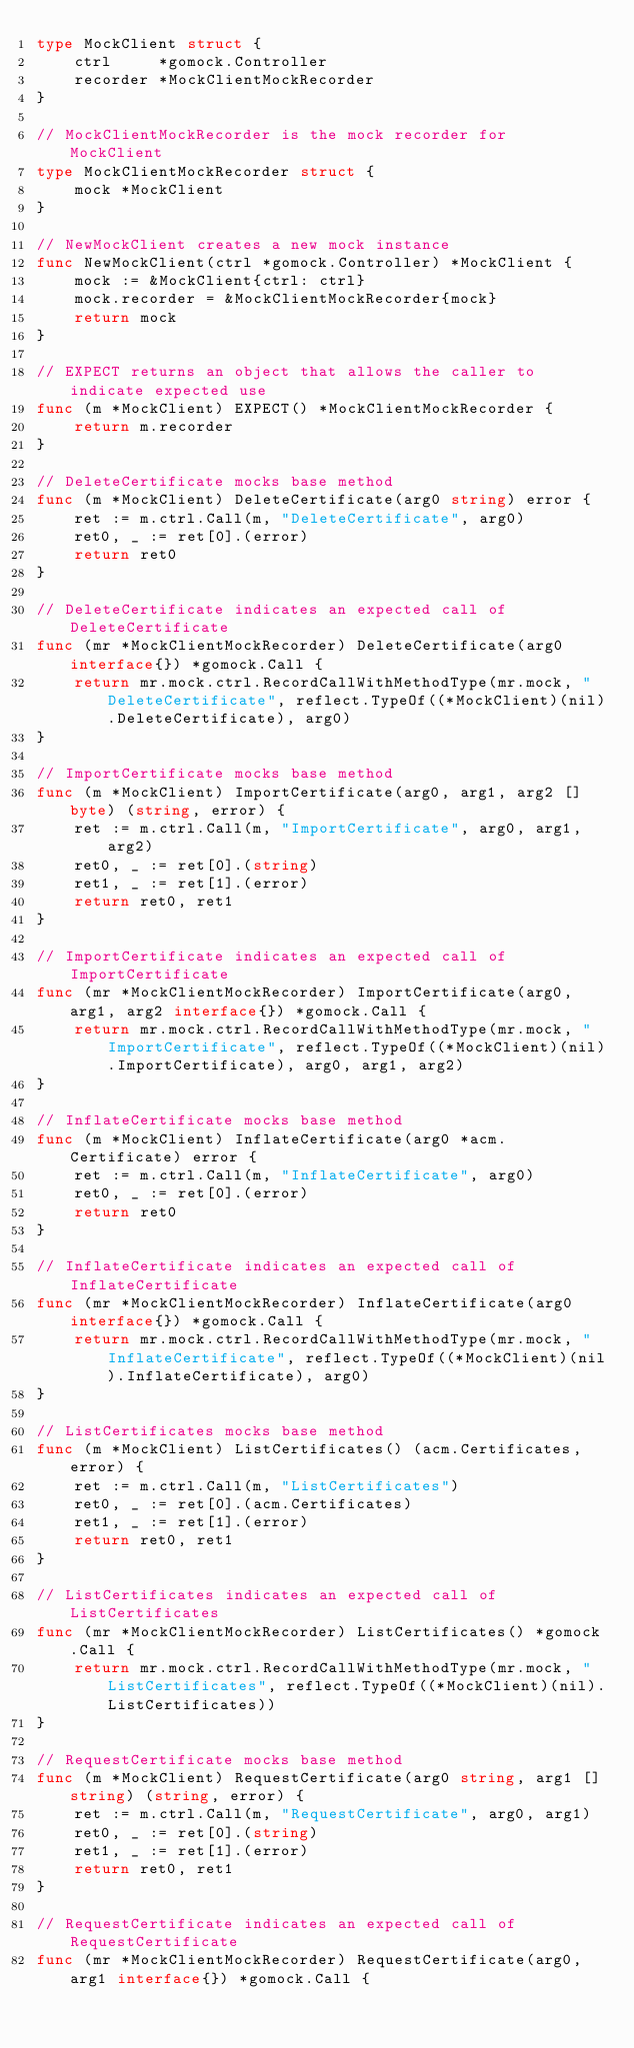<code> <loc_0><loc_0><loc_500><loc_500><_Go_>type MockClient struct {
	ctrl     *gomock.Controller
	recorder *MockClientMockRecorder
}

// MockClientMockRecorder is the mock recorder for MockClient
type MockClientMockRecorder struct {
	mock *MockClient
}

// NewMockClient creates a new mock instance
func NewMockClient(ctrl *gomock.Controller) *MockClient {
	mock := &MockClient{ctrl: ctrl}
	mock.recorder = &MockClientMockRecorder{mock}
	return mock
}

// EXPECT returns an object that allows the caller to indicate expected use
func (m *MockClient) EXPECT() *MockClientMockRecorder {
	return m.recorder
}

// DeleteCertificate mocks base method
func (m *MockClient) DeleteCertificate(arg0 string) error {
	ret := m.ctrl.Call(m, "DeleteCertificate", arg0)
	ret0, _ := ret[0].(error)
	return ret0
}

// DeleteCertificate indicates an expected call of DeleteCertificate
func (mr *MockClientMockRecorder) DeleteCertificate(arg0 interface{}) *gomock.Call {
	return mr.mock.ctrl.RecordCallWithMethodType(mr.mock, "DeleteCertificate", reflect.TypeOf((*MockClient)(nil).DeleteCertificate), arg0)
}

// ImportCertificate mocks base method
func (m *MockClient) ImportCertificate(arg0, arg1, arg2 []byte) (string, error) {
	ret := m.ctrl.Call(m, "ImportCertificate", arg0, arg1, arg2)
	ret0, _ := ret[0].(string)
	ret1, _ := ret[1].(error)
	return ret0, ret1
}

// ImportCertificate indicates an expected call of ImportCertificate
func (mr *MockClientMockRecorder) ImportCertificate(arg0, arg1, arg2 interface{}) *gomock.Call {
	return mr.mock.ctrl.RecordCallWithMethodType(mr.mock, "ImportCertificate", reflect.TypeOf((*MockClient)(nil).ImportCertificate), arg0, arg1, arg2)
}

// InflateCertificate mocks base method
func (m *MockClient) InflateCertificate(arg0 *acm.Certificate) error {
	ret := m.ctrl.Call(m, "InflateCertificate", arg0)
	ret0, _ := ret[0].(error)
	return ret0
}

// InflateCertificate indicates an expected call of InflateCertificate
func (mr *MockClientMockRecorder) InflateCertificate(arg0 interface{}) *gomock.Call {
	return mr.mock.ctrl.RecordCallWithMethodType(mr.mock, "InflateCertificate", reflect.TypeOf((*MockClient)(nil).InflateCertificate), arg0)
}

// ListCertificates mocks base method
func (m *MockClient) ListCertificates() (acm.Certificates, error) {
	ret := m.ctrl.Call(m, "ListCertificates")
	ret0, _ := ret[0].(acm.Certificates)
	ret1, _ := ret[1].(error)
	return ret0, ret1
}

// ListCertificates indicates an expected call of ListCertificates
func (mr *MockClientMockRecorder) ListCertificates() *gomock.Call {
	return mr.mock.ctrl.RecordCallWithMethodType(mr.mock, "ListCertificates", reflect.TypeOf((*MockClient)(nil).ListCertificates))
}

// RequestCertificate mocks base method
func (m *MockClient) RequestCertificate(arg0 string, arg1 []string) (string, error) {
	ret := m.ctrl.Call(m, "RequestCertificate", arg0, arg1)
	ret0, _ := ret[0].(string)
	ret1, _ := ret[1].(error)
	return ret0, ret1
}

// RequestCertificate indicates an expected call of RequestCertificate
func (mr *MockClientMockRecorder) RequestCertificate(arg0, arg1 interface{}) *gomock.Call {</code> 